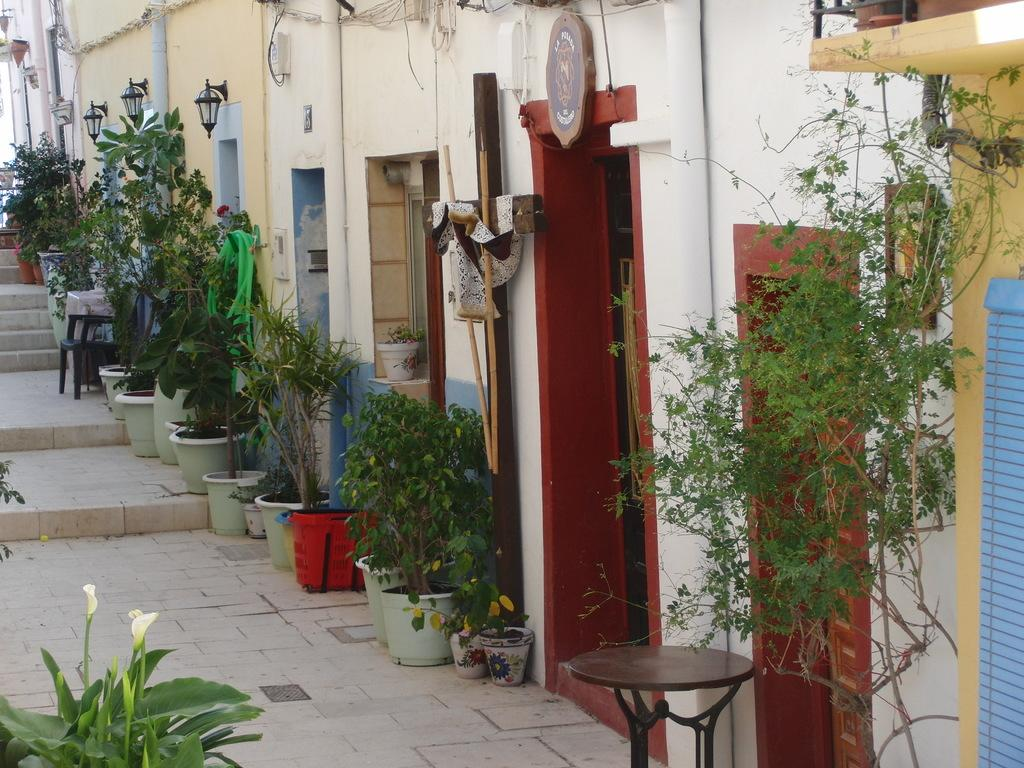What can be seen in front of the doors in the image? There are flower pots in front of the doors. How would you describe the appearance of the buildings in the image? There are small buildings with colorful doors. What type of vegetation is visible on the left side of the image? There are small plants on the left side of the image. Can you hear the argument between the flowers in the image? There are no flowers or any audible sounds in the image, so it is not possible to hear an argument. 